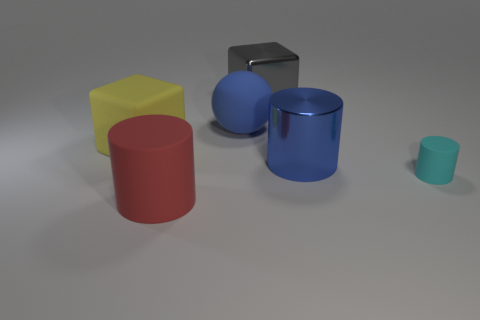There is a gray shiny object that is left of the cyan object; what is its size?
Keep it short and to the point. Large. What shape is the big object that is the same color as the big matte ball?
Offer a very short reply. Cylinder. What shape is the yellow thing on the left side of the large metallic thing right of the cube that is on the right side of the big yellow block?
Your answer should be compact. Cube. What number of other things are there of the same shape as the big blue metal object?
Offer a terse response. 2. What number of rubber objects are either blue cylinders or tiny gray balls?
Your response must be concise. 0. There is a big block behind the large matte thing that is behind the big yellow rubber thing; what is its material?
Your answer should be compact. Metal. Is the number of gray shiny blocks left of the large gray thing greater than the number of gray blocks?
Your response must be concise. No. Are there any big gray things that have the same material as the small cylinder?
Offer a terse response. No. Does the large object in front of the big blue cylinder have the same shape as the tiny cyan thing?
Ensure brevity in your answer.  Yes. What number of yellow matte things are in front of the cylinder in front of the cyan matte cylinder on the right side of the large rubber sphere?
Offer a very short reply. 0. 